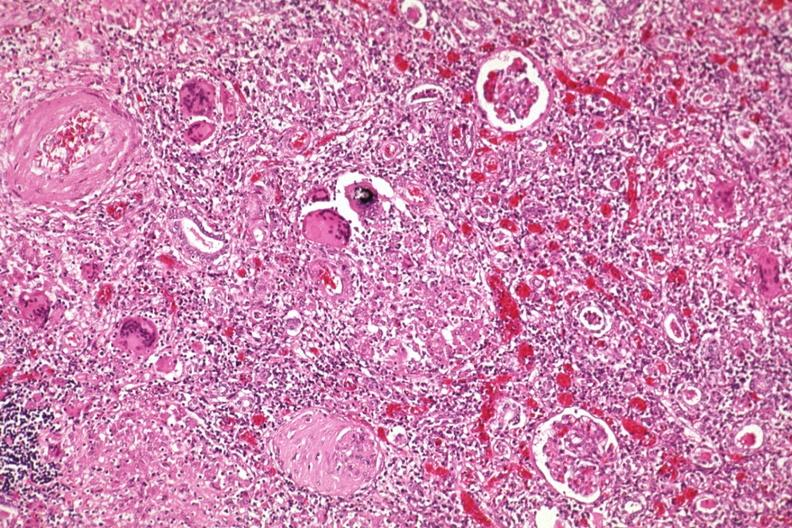what does this image show?
Answer the question using a single word or phrase. Giant cells 